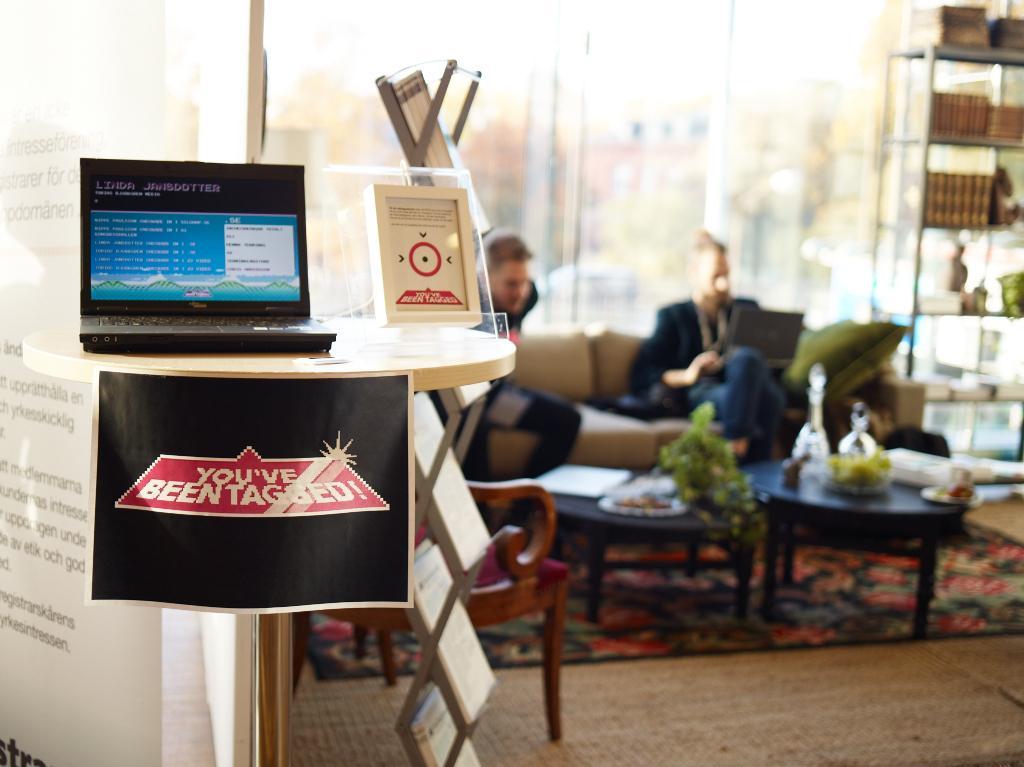How would you summarize this image in a sentence or two? In this picture, to the left there is a laptop and shield on the table. A paper is attached to the table and some text printed on it. To the right there is a bookshelf with random objects placed in a desk. In the center there is a sofa,two men were sitting on it, one person holding a laptop. There were two tables in front of the sofa and there were random objects placed on the table. There is a mat covered on the floor. 